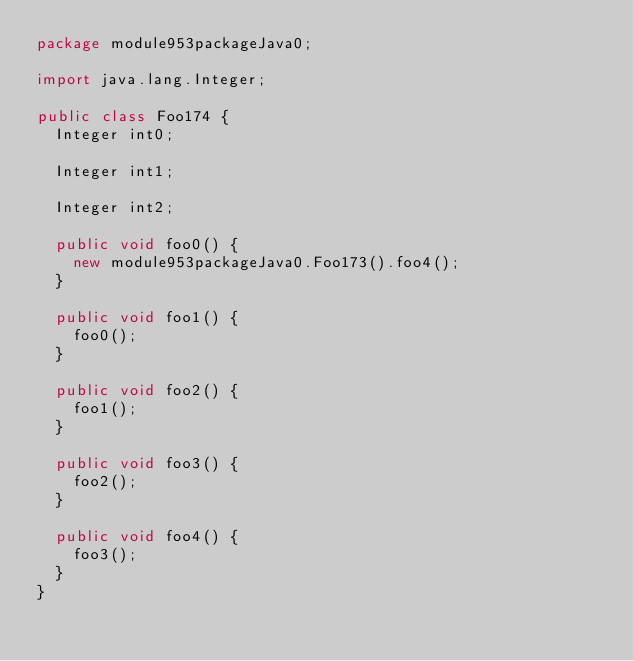Convert code to text. <code><loc_0><loc_0><loc_500><loc_500><_Java_>package module953packageJava0;

import java.lang.Integer;

public class Foo174 {
  Integer int0;

  Integer int1;

  Integer int2;

  public void foo0() {
    new module953packageJava0.Foo173().foo4();
  }

  public void foo1() {
    foo0();
  }

  public void foo2() {
    foo1();
  }

  public void foo3() {
    foo2();
  }

  public void foo4() {
    foo3();
  }
}
</code> 